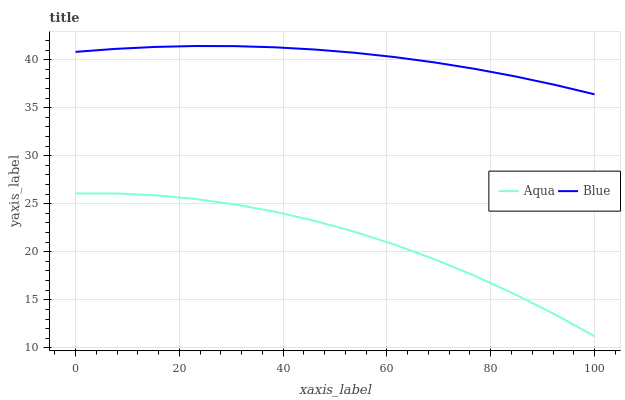Does Aqua have the maximum area under the curve?
Answer yes or no. No. Is Aqua the smoothest?
Answer yes or no. No. Does Aqua have the highest value?
Answer yes or no. No. Is Aqua less than Blue?
Answer yes or no. Yes. Is Blue greater than Aqua?
Answer yes or no. Yes. Does Aqua intersect Blue?
Answer yes or no. No. 